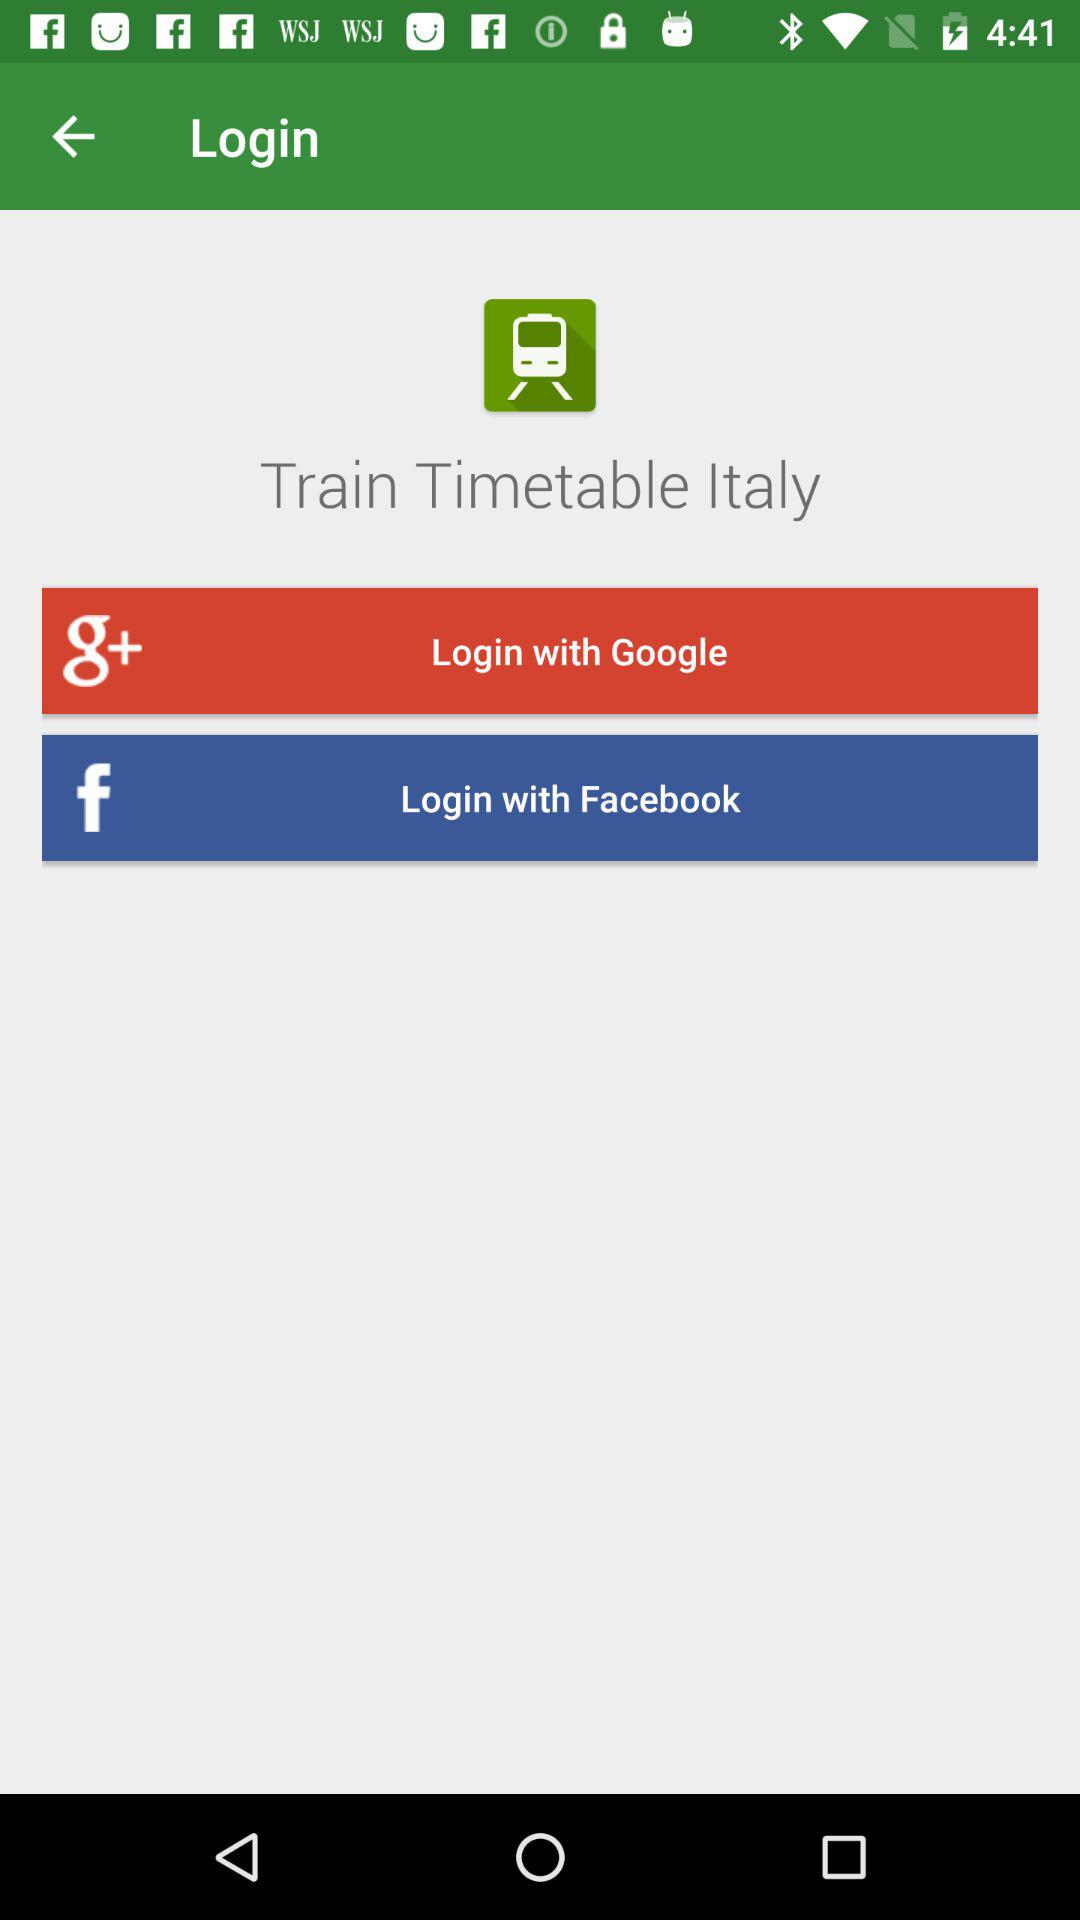What is the application name? The application name is "Train Timetable Italy". 